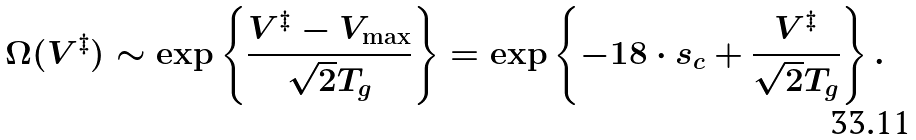Convert formula to latex. <formula><loc_0><loc_0><loc_500><loc_500>\Omega ( V ^ { \ddagger } ) \sim \exp \left \{ \frac { V ^ { \ddagger } - V _ { \max } } { \sqrt { 2 } T _ { g } } \right \} = \exp \left \{ - 1 8 \cdot s _ { c } + \frac { V ^ { \ddagger } } { \sqrt { 2 } T _ { g } } \right \} .</formula> 